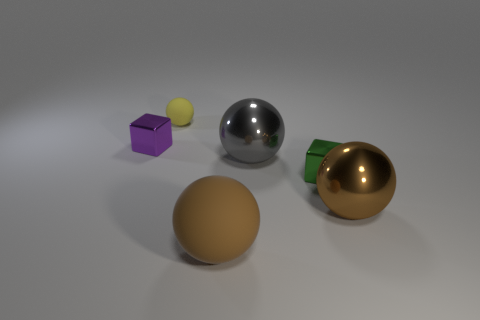Can you describe the setting of this image? The image features an assortment of objects with various colors and finishes, presented on a neutral, flat surface. The setting appears to be a simple 3D rendering or possibly a studio setup designed to highlight the objects without any distracting background elements. 